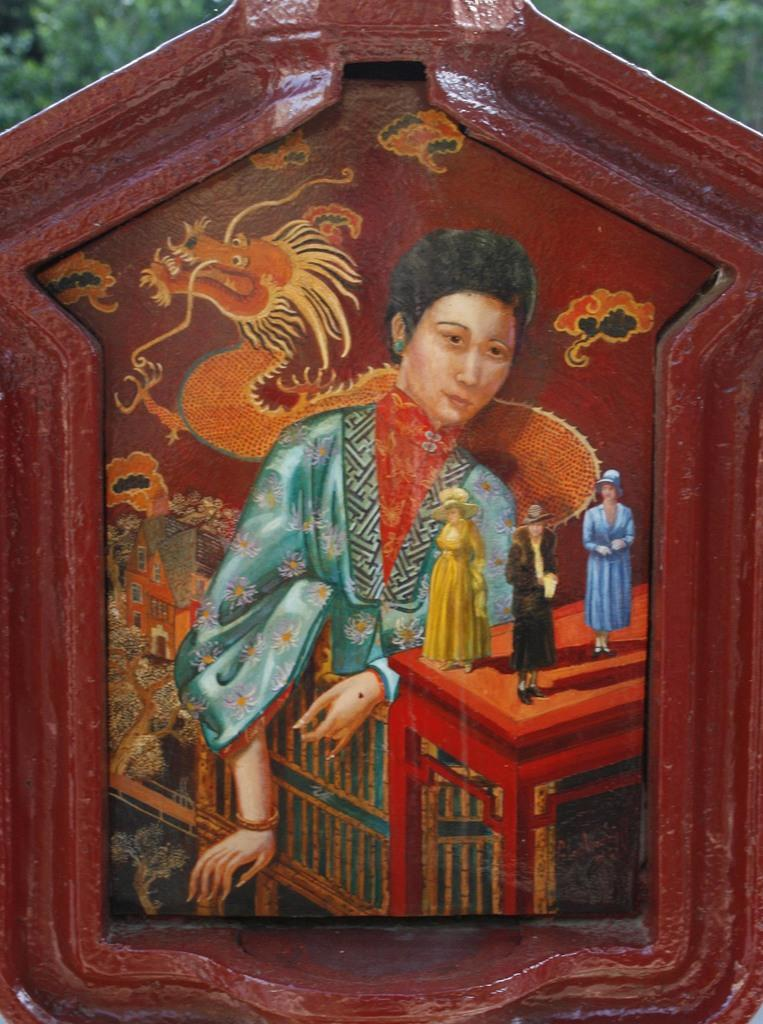What is the main object in the image? There is a board in the image. What is shown on the board? People, buildings, and a snake are depicted on the board. What is the color of the background in the image? The background of the image appears to be green. How many pieces of lumber are being used to build the depicted buildings on the board? There is no information about lumber or the construction of the buildings in the image. What type of education is being taught on the board? There is no indication of any educational content on the board; it depicts people, buildings, and a snake. 